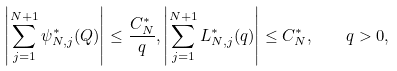Convert formula to latex. <formula><loc_0><loc_0><loc_500><loc_500>\left | \sum _ { j = 1 } ^ { N + 1 } \psi _ { N , j } ^ { \ast } ( Q ) \right | \leq \frac { C _ { N } ^ { \ast } } { q } , \left | \sum _ { j = 1 } ^ { N + 1 } L _ { N , j } ^ { \ast } ( q ) \right | \leq C _ { N } ^ { \ast } , \quad q > 0 ,</formula> 